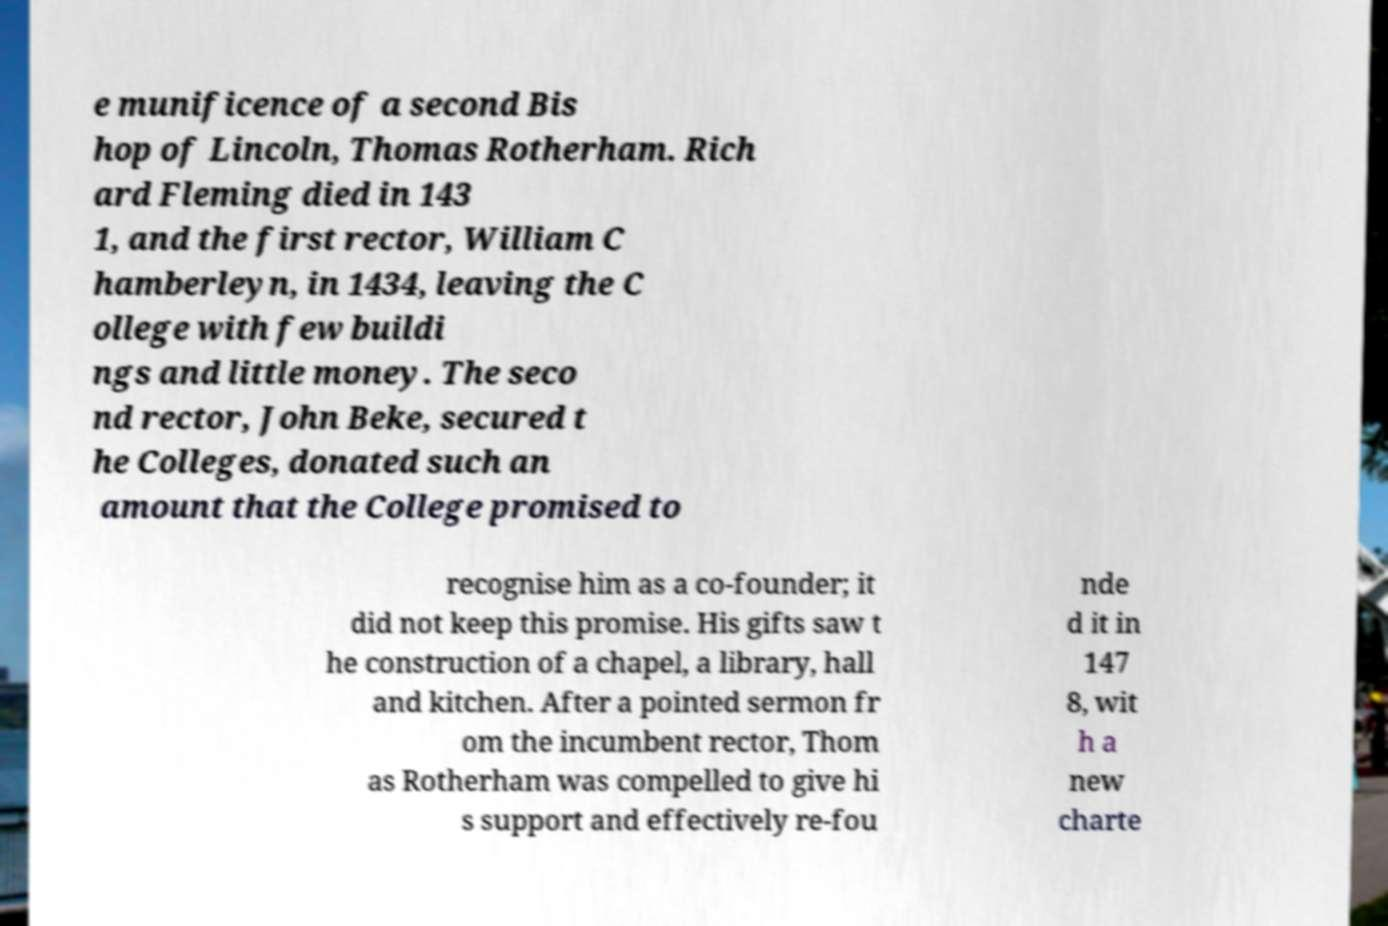What messages or text are displayed in this image? I need them in a readable, typed format. e munificence of a second Bis hop of Lincoln, Thomas Rotherham. Rich ard Fleming died in 143 1, and the first rector, William C hamberleyn, in 1434, leaving the C ollege with few buildi ngs and little money. The seco nd rector, John Beke, secured t he Colleges, donated such an amount that the College promised to recognise him as a co-founder; it did not keep this promise. His gifts saw t he construction of a chapel, a library, hall and kitchen. After a pointed sermon fr om the incumbent rector, Thom as Rotherham was compelled to give hi s support and effectively re-fou nde d it in 147 8, wit h a new charte 